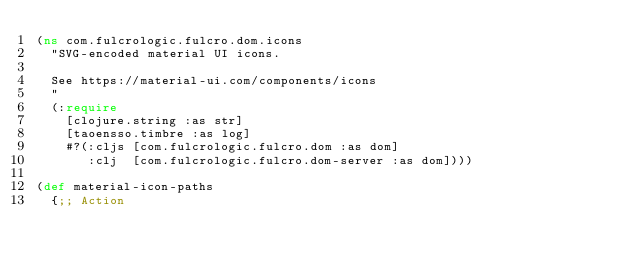Convert code to text. <code><loc_0><loc_0><loc_500><loc_500><_Clojure_>(ns com.fulcrologic.fulcro.dom.icons
  "SVG-encoded material UI icons.

  See https://material-ui.com/components/icons
  "
  (:require
    [clojure.string :as str]
    [taoensso.timbre :as log]
    #?(:cljs [com.fulcrologic.fulcro.dom :as dom]
       :clj  [com.fulcrologic.fulcro.dom-server :as dom])))

(def material-icon-paths
  {;; Action</code> 